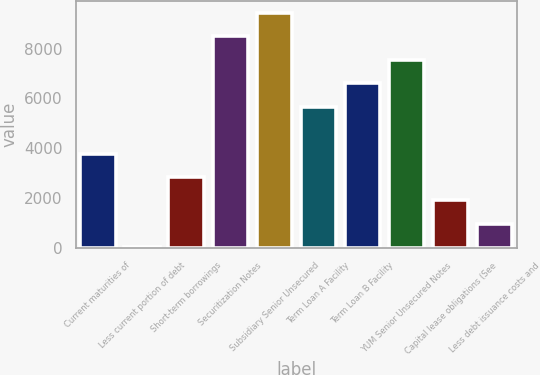<chart> <loc_0><loc_0><loc_500><loc_500><bar_chart><fcel>Current maturities of<fcel>Less current portion of debt<fcel>Short-term borrowings<fcel>Securitization Notes<fcel>Subsidiary Senior Unsecured<fcel>Term Loan A Facility<fcel>Term Loan B Facility<fcel>YUM Senior Unsecured Notes<fcel>Capital lease obligations (See<fcel>Less debt issuance costs and<nl><fcel>3778.2<fcel>11<fcel>2836.4<fcel>8487.2<fcel>9429<fcel>5661.8<fcel>6603.6<fcel>7545.4<fcel>1894.6<fcel>952.8<nl></chart> 